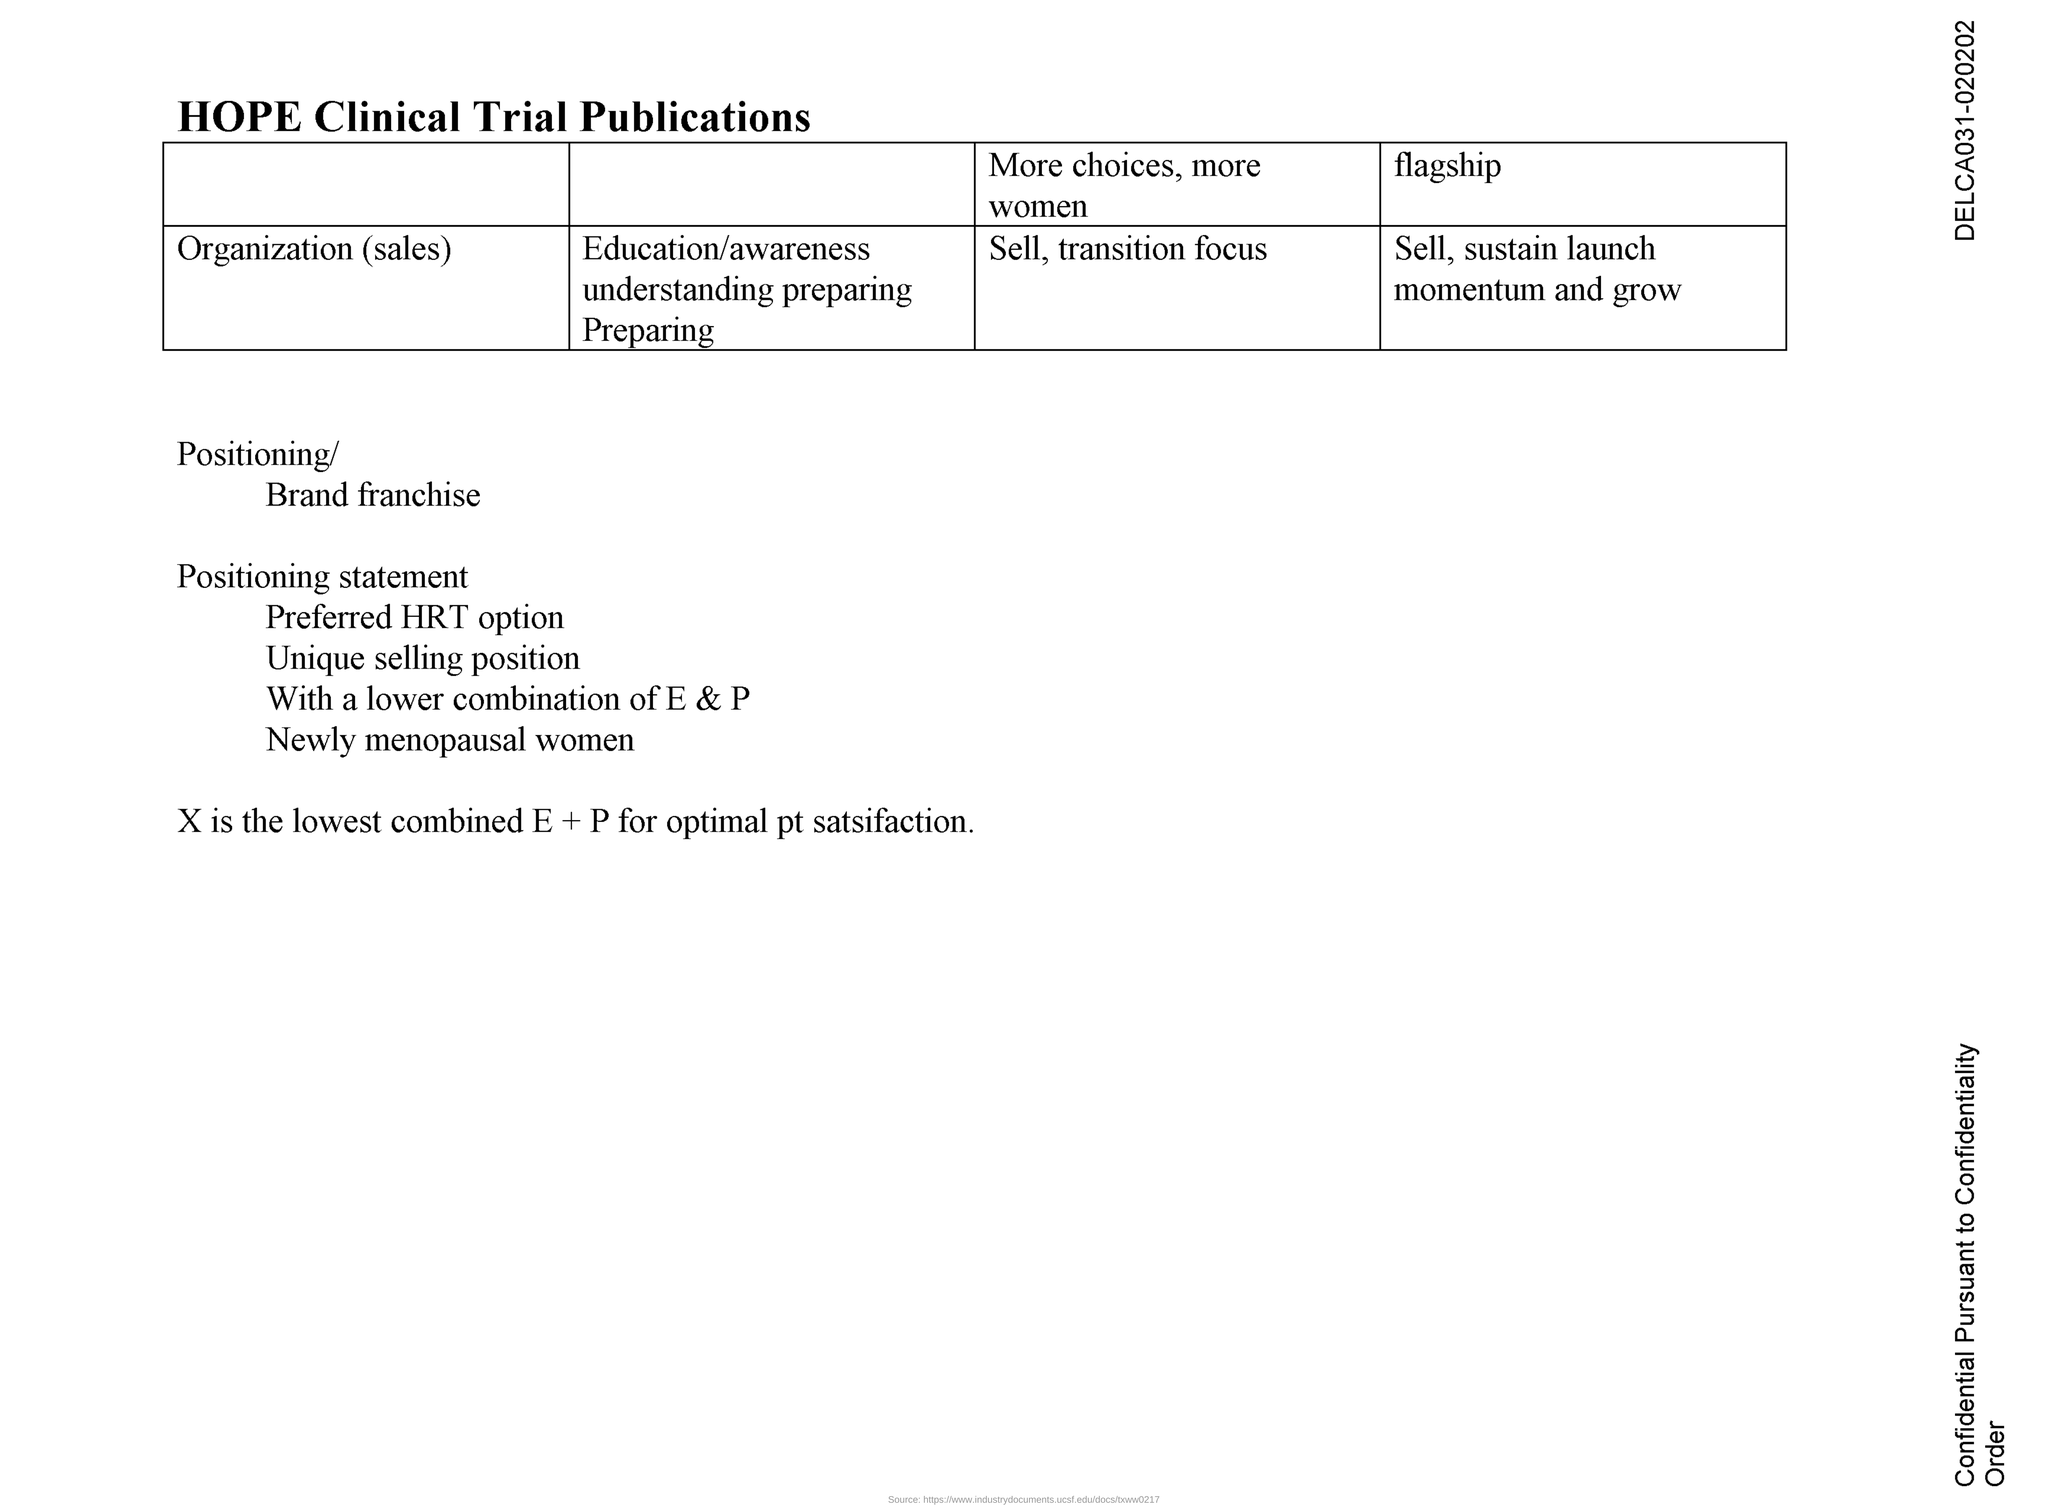What is the title of the document?
Offer a very short reply. HOPE Clinical Trial Publications. What is the title of the fourth column of the table?
Your answer should be compact. Flagship. 